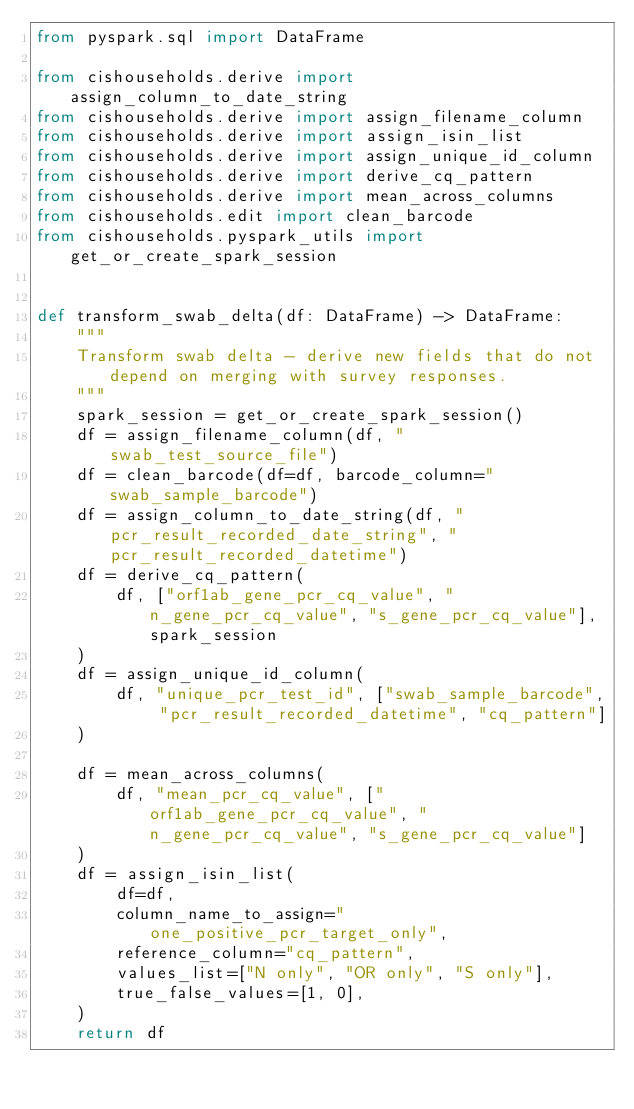<code> <loc_0><loc_0><loc_500><loc_500><_Python_>from pyspark.sql import DataFrame

from cishouseholds.derive import assign_column_to_date_string
from cishouseholds.derive import assign_filename_column
from cishouseholds.derive import assign_isin_list
from cishouseholds.derive import assign_unique_id_column
from cishouseholds.derive import derive_cq_pattern
from cishouseholds.derive import mean_across_columns
from cishouseholds.edit import clean_barcode
from cishouseholds.pyspark_utils import get_or_create_spark_session


def transform_swab_delta(df: DataFrame) -> DataFrame:
    """
    Transform swab delta - derive new fields that do not depend on merging with survey responses.
    """
    spark_session = get_or_create_spark_session()
    df = assign_filename_column(df, "swab_test_source_file")
    df = clean_barcode(df=df, barcode_column="swab_sample_barcode")
    df = assign_column_to_date_string(df, "pcr_result_recorded_date_string", "pcr_result_recorded_datetime")
    df = derive_cq_pattern(
        df, ["orf1ab_gene_pcr_cq_value", "n_gene_pcr_cq_value", "s_gene_pcr_cq_value"], spark_session
    )
    df = assign_unique_id_column(
        df, "unique_pcr_test_id", ["swab_sample_barcode", "pcr_result_recorded_datetime", "cq_pattern"]
    )

    df = mean_across_columns(
        df, "mean_pcr_cq_value", ["orf1ab_gene_pcr_cq_value", "n_gene_pcr_cq_value", "s_gene_pcr_cq_value"]
    )
    df = assign_isin_list(
        df=df,
        column_name_to_assign="one_positive_pcr_target_only",
        reference_column="cq_pattern",
        values_list=["N only", "OR only", "S only"],
        true_false_values=[1, 0],
    )
    return df
</code> 